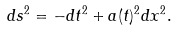<formula> <loc_0><loc_0><loc_500><loc_500>d s ^ { 2 } = - d t ^ { 2 } + a ( t ) ^ { 2 } d x ^ { 2 } .</formula> 